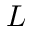<formula> <loc_0><loc_0><loc_500><loc_500>L</formula> 